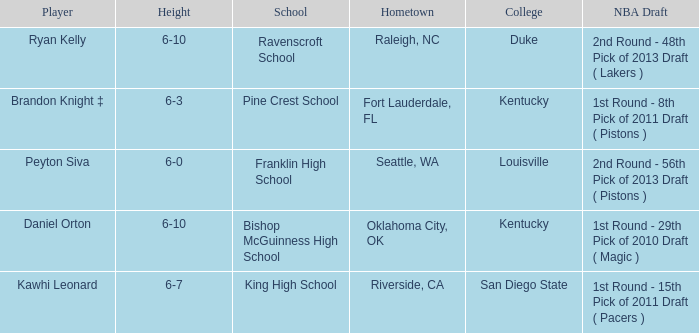Which school is in Raleigh, NC? Ravenscroft School. 